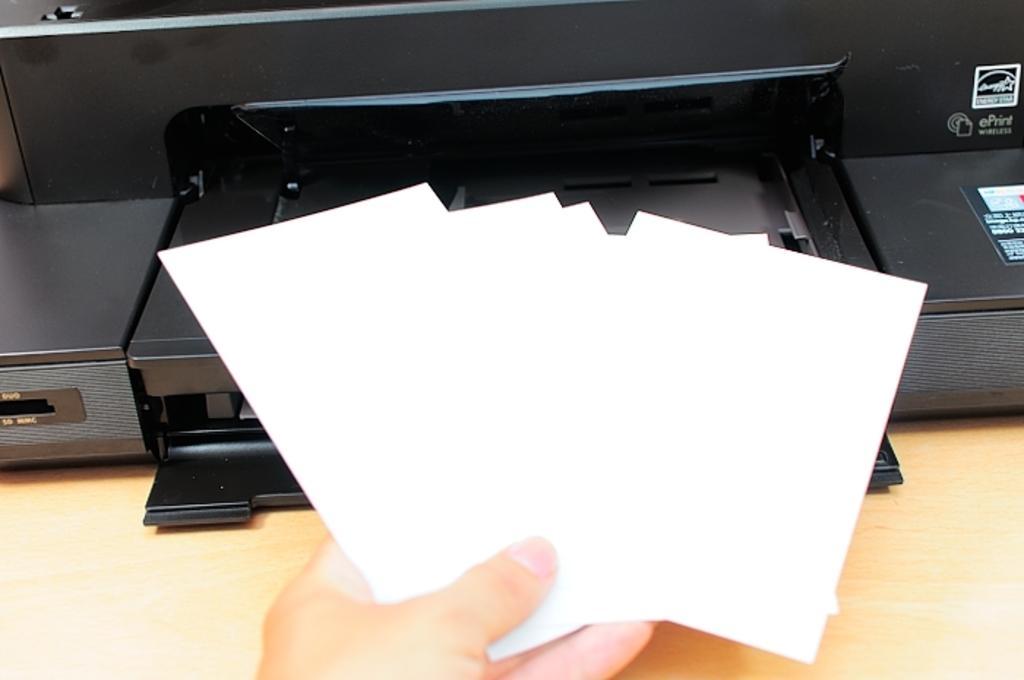Can you describe this image briefly? In this image I can see a person's hand holding some cards. In the background it looks like a printer or some object. 